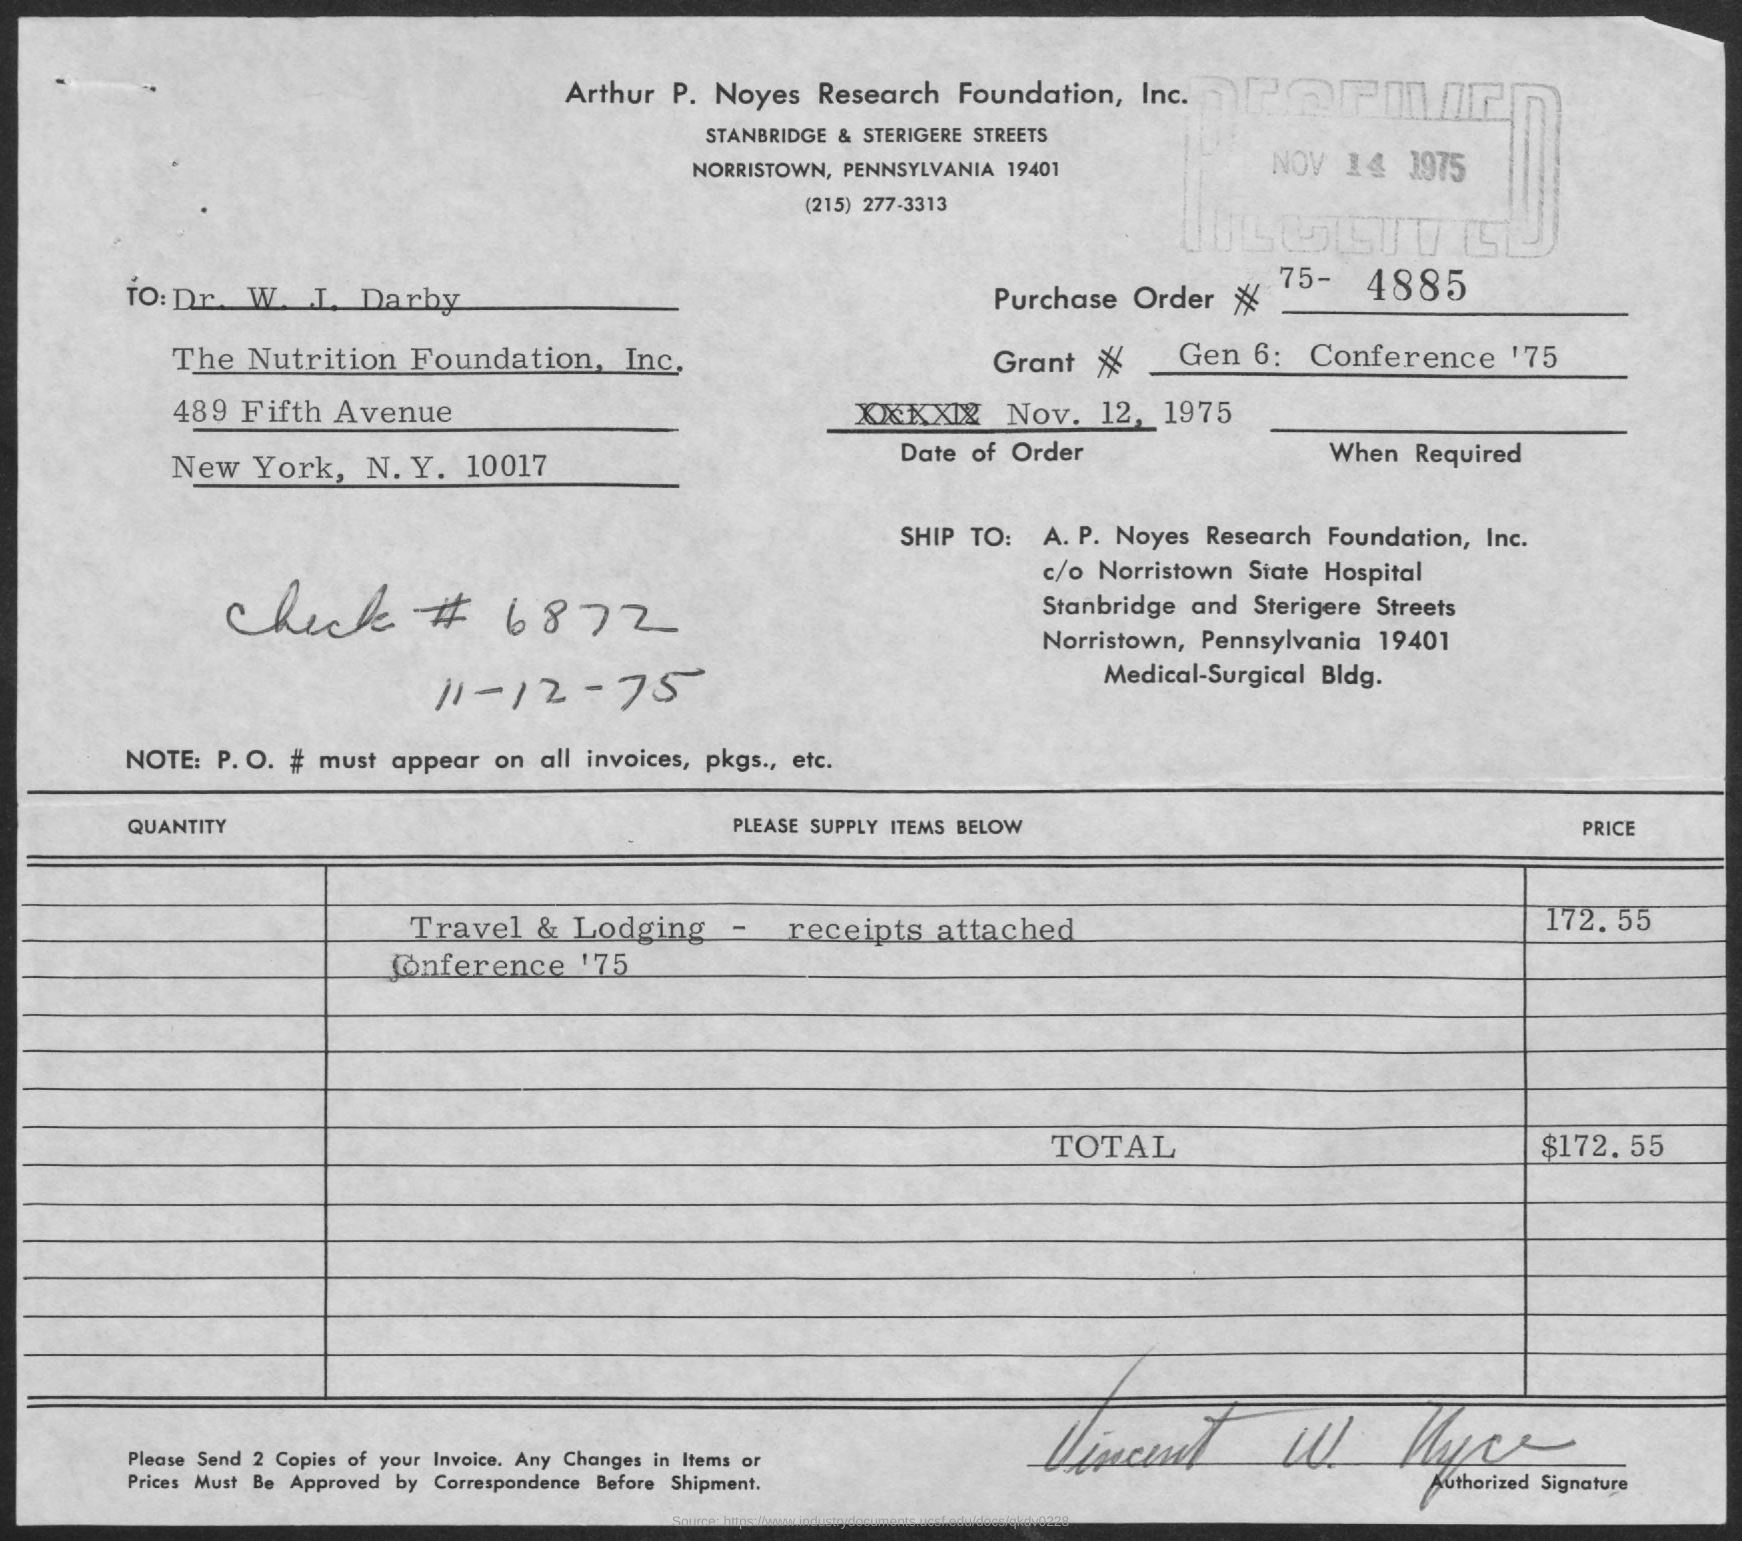What is the Grant #(no) given in this document?
Offer a terse response. Gen 6:   Conference '75. What is the date of order mentioned in this document?
Keep it short and to the point. Nov. 12, 1975. What is the Check #(no) mentioned in the document?
Ensure brevity in your answer.  6872. What is the total invoice amount as per the document?
Provide a short and direct response. $172 55. 